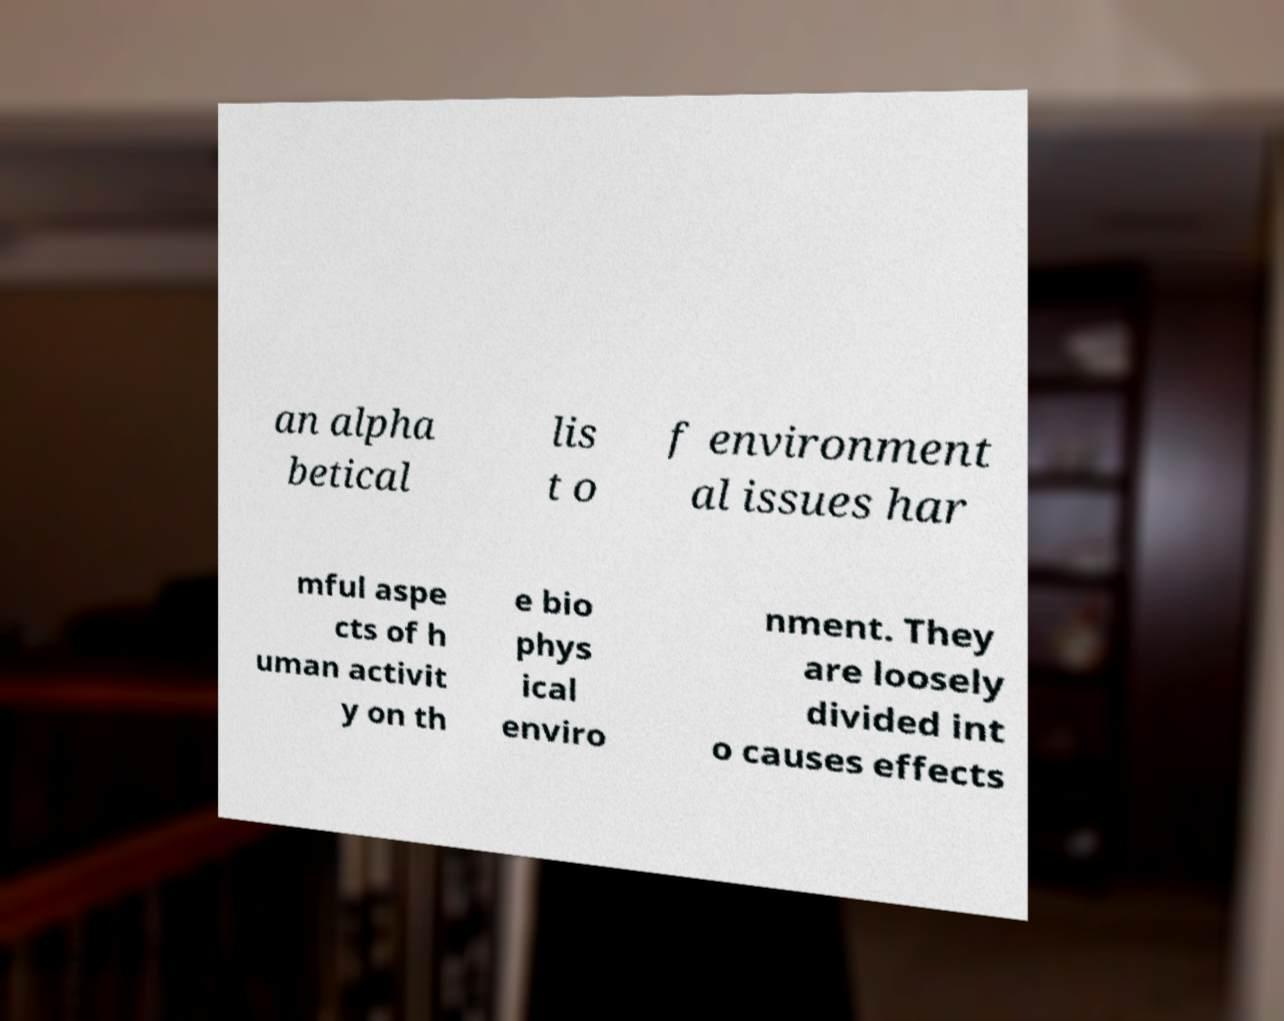For documentation purposes, I need the text within this image transcribed. Could you provide that? an alpha betical lis t o f environment al issues har mful aspe cts of h uman activit y on th e bio phys ical enviro nment. They are loosely divided int o causes effects 